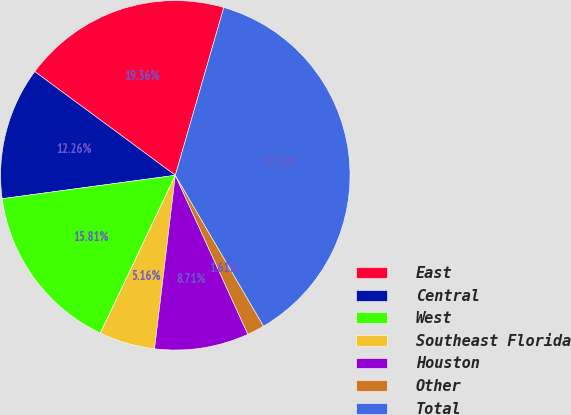Convert chart. <chart><loc_0><loc_0><loc_500><loc_500><pie_chart><fcel>East<fcel>Central<fcel>West<fcel>Southeast Florida<fcel>Houston<fcel>Other<fcel>Total<nl><fcel>19.36%<fcel>12.26%<fcel>15.81%<fcel>5.16%<fcel>8.71%<fcel>1.61%<fcel>37.11%<nl></chart> 